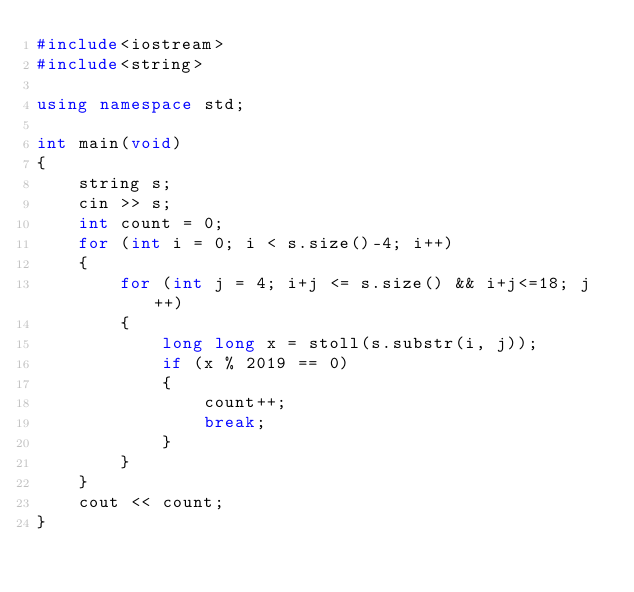<code> <loc_0><loc_0><loc_500><loc_500><_C++_>#include<iostream>
#include<string>

using namespace std;

int main(void)
{
	string s;
	cin >> s;
	int count = 0;
	for (int i = 0; i < s.size()-4; i++)
	{
		for (int j = 4; i+j <= s.size() && i+j<=18; j++)
		{
			long long x = stoll(s.substr(i, j));
			if (x % 2019 == 0)
			{
				count++;
				break;
			}
		}
	}
	cout << count;
}</code> 